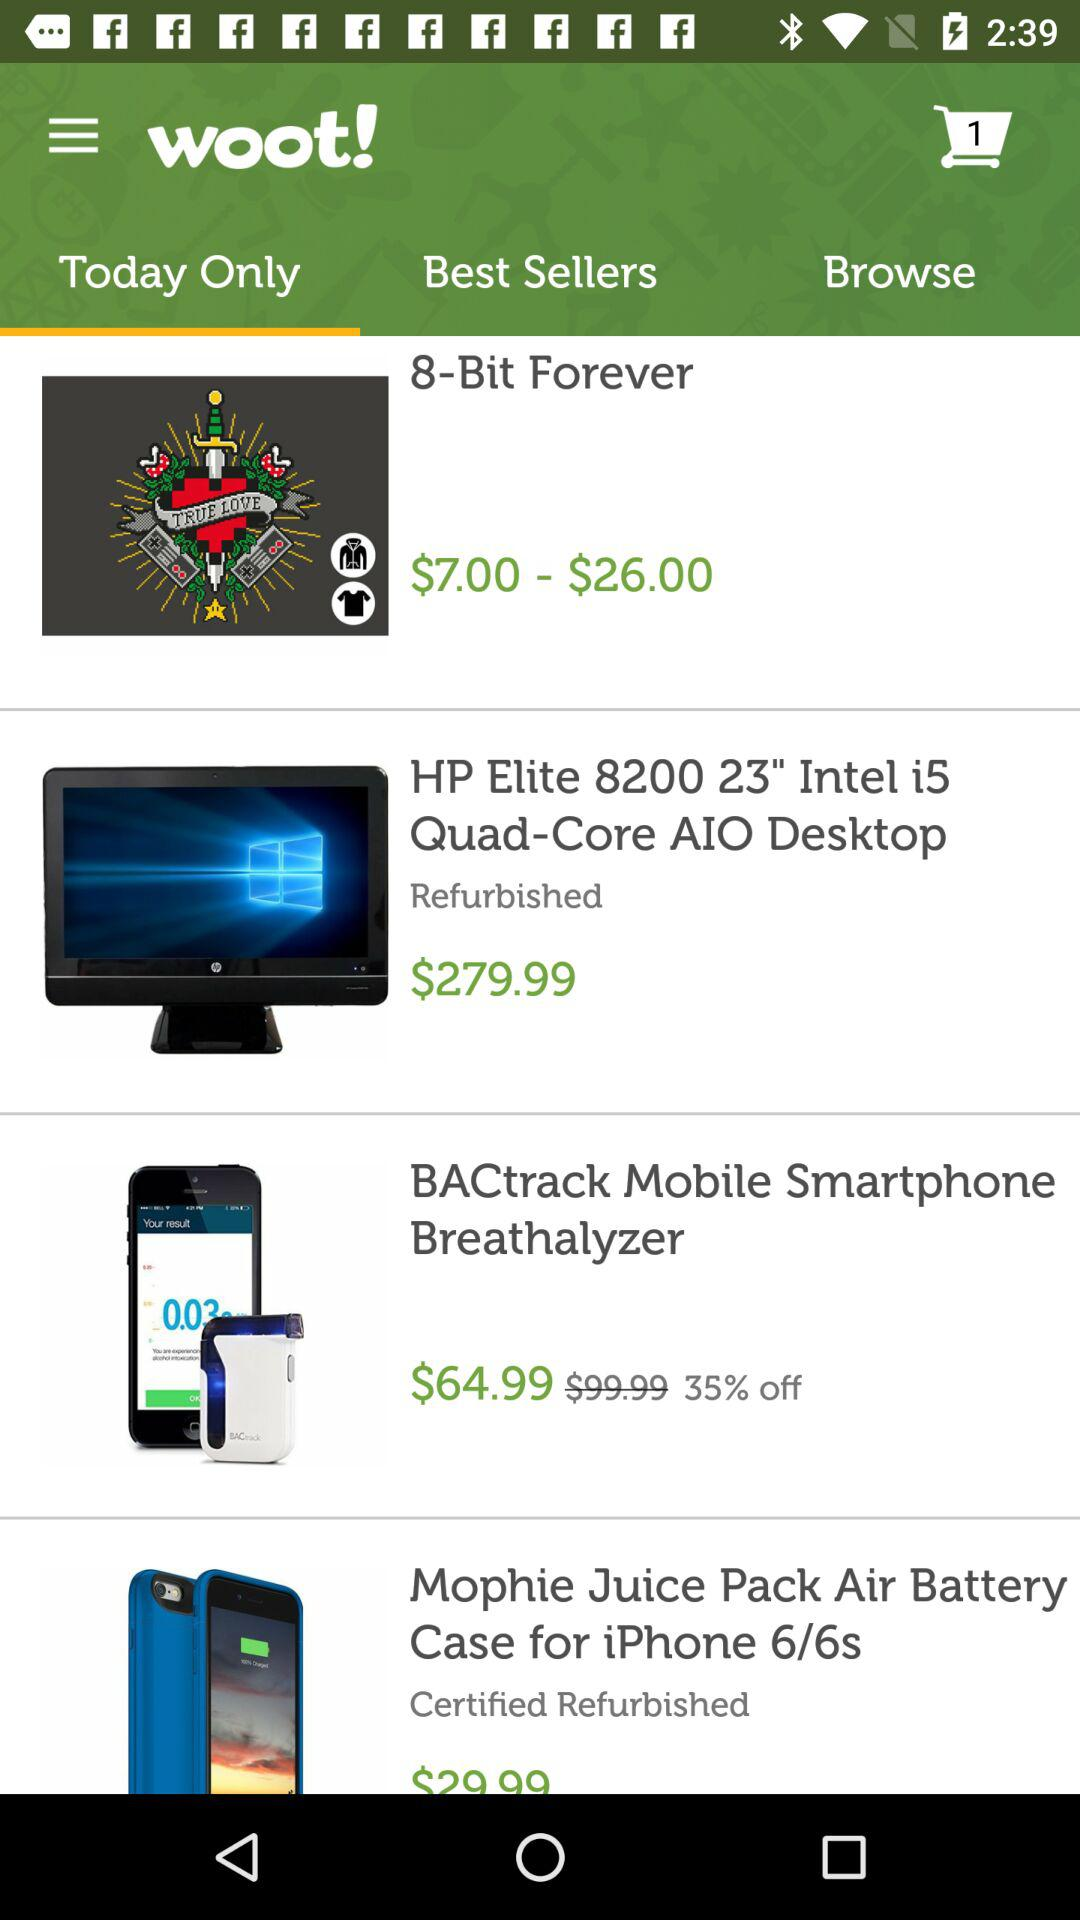How much is off on the "BACtrack Mobile Smartphone Breathalyzer"? There is 35% off on the "BACtrack Mobile Smartphone Breathalyzer". 